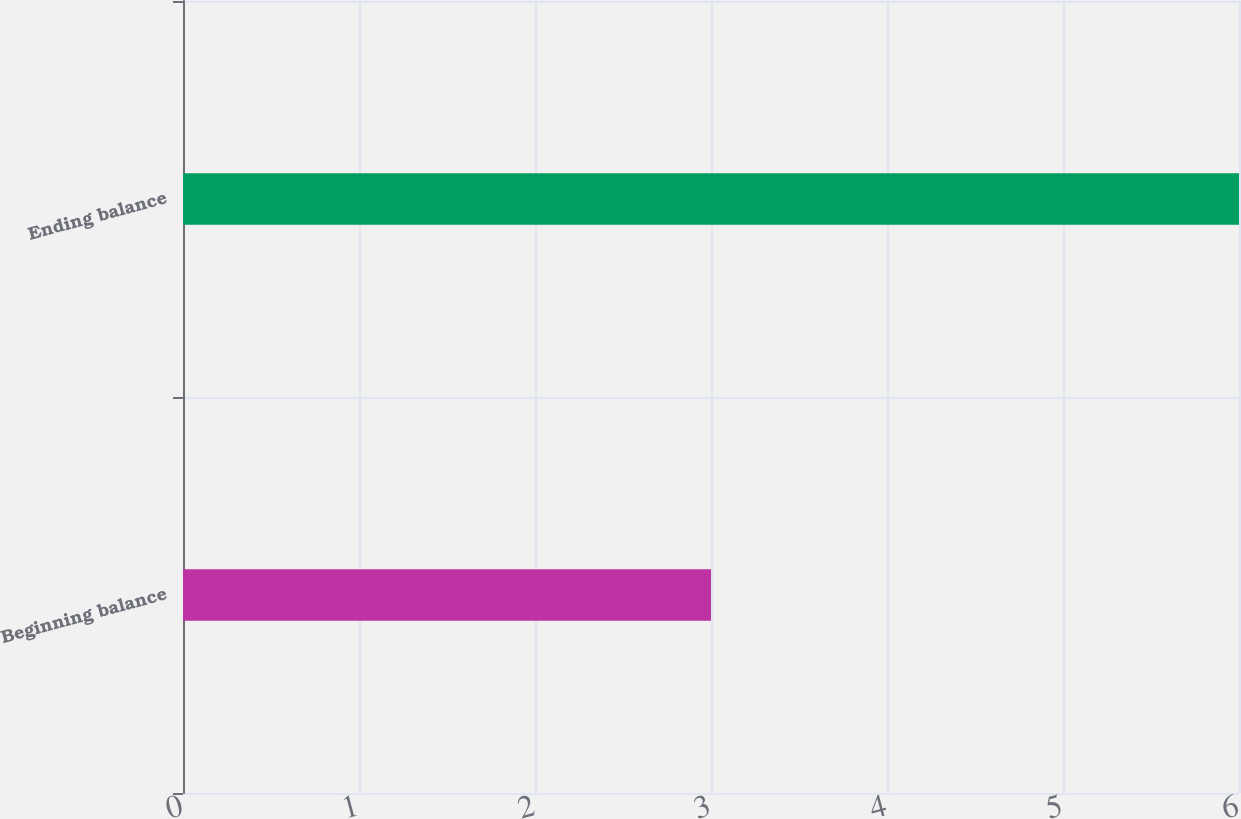Convert chart to OTSL. <chart><loc_0><loc_0><loc_500><loc_500><bar_chart><fcel>Beginning balance<fcel>Ending balance<nl><fcel>3<fcel>6<nl></chart> 